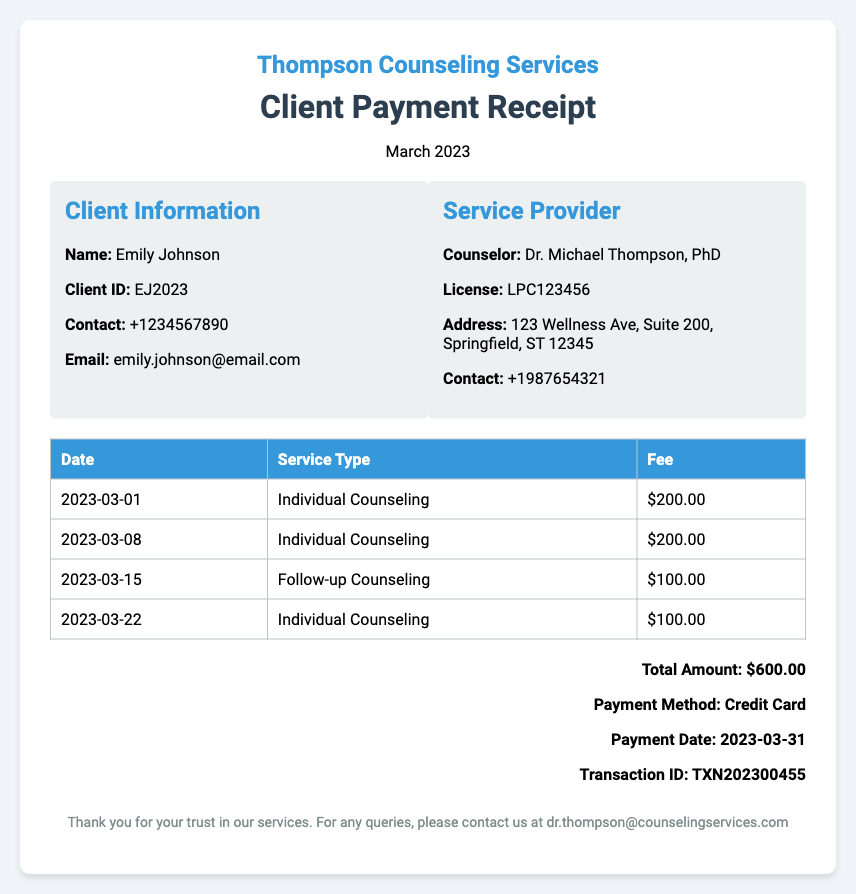What is the total amount? The total amount is the sum of fees for the services rendered, which is $200.00 + $200.00 + $100.00 + $100.00 = $600.00.
Answer: $600.00 What is the client's name? The client's name is displayed prominently in the document under Client Information.
Answer: Emily Johnson What method of payment was used? The payment method is listed in the total section of the document.
Answer: Credit Card How many individual counseling sessions were held? The number of sessions can be counted from the session dates listed in the table.
Answer: Three What is the date of the last counseling session? The last session date can be found in the list of services provided in the table.
Answer: 2023-03-22 What is the transaction ID? The transaction ID is specified in the payment details section of the document.
Answer: TXN202300455 Who is the counselor? The counselor's name is mentioned in the service provider's section of the document.
Answer: Dr. Michael Thompson, PhD What is the fee for follow-up counseling? The fee for follow-up counseling can be found in the fees table within the document.
Answer: $100.00 On what date was the payment made? The payment date is included in the payment details section at the bottom of the document.
Answer: 2023-03-31 